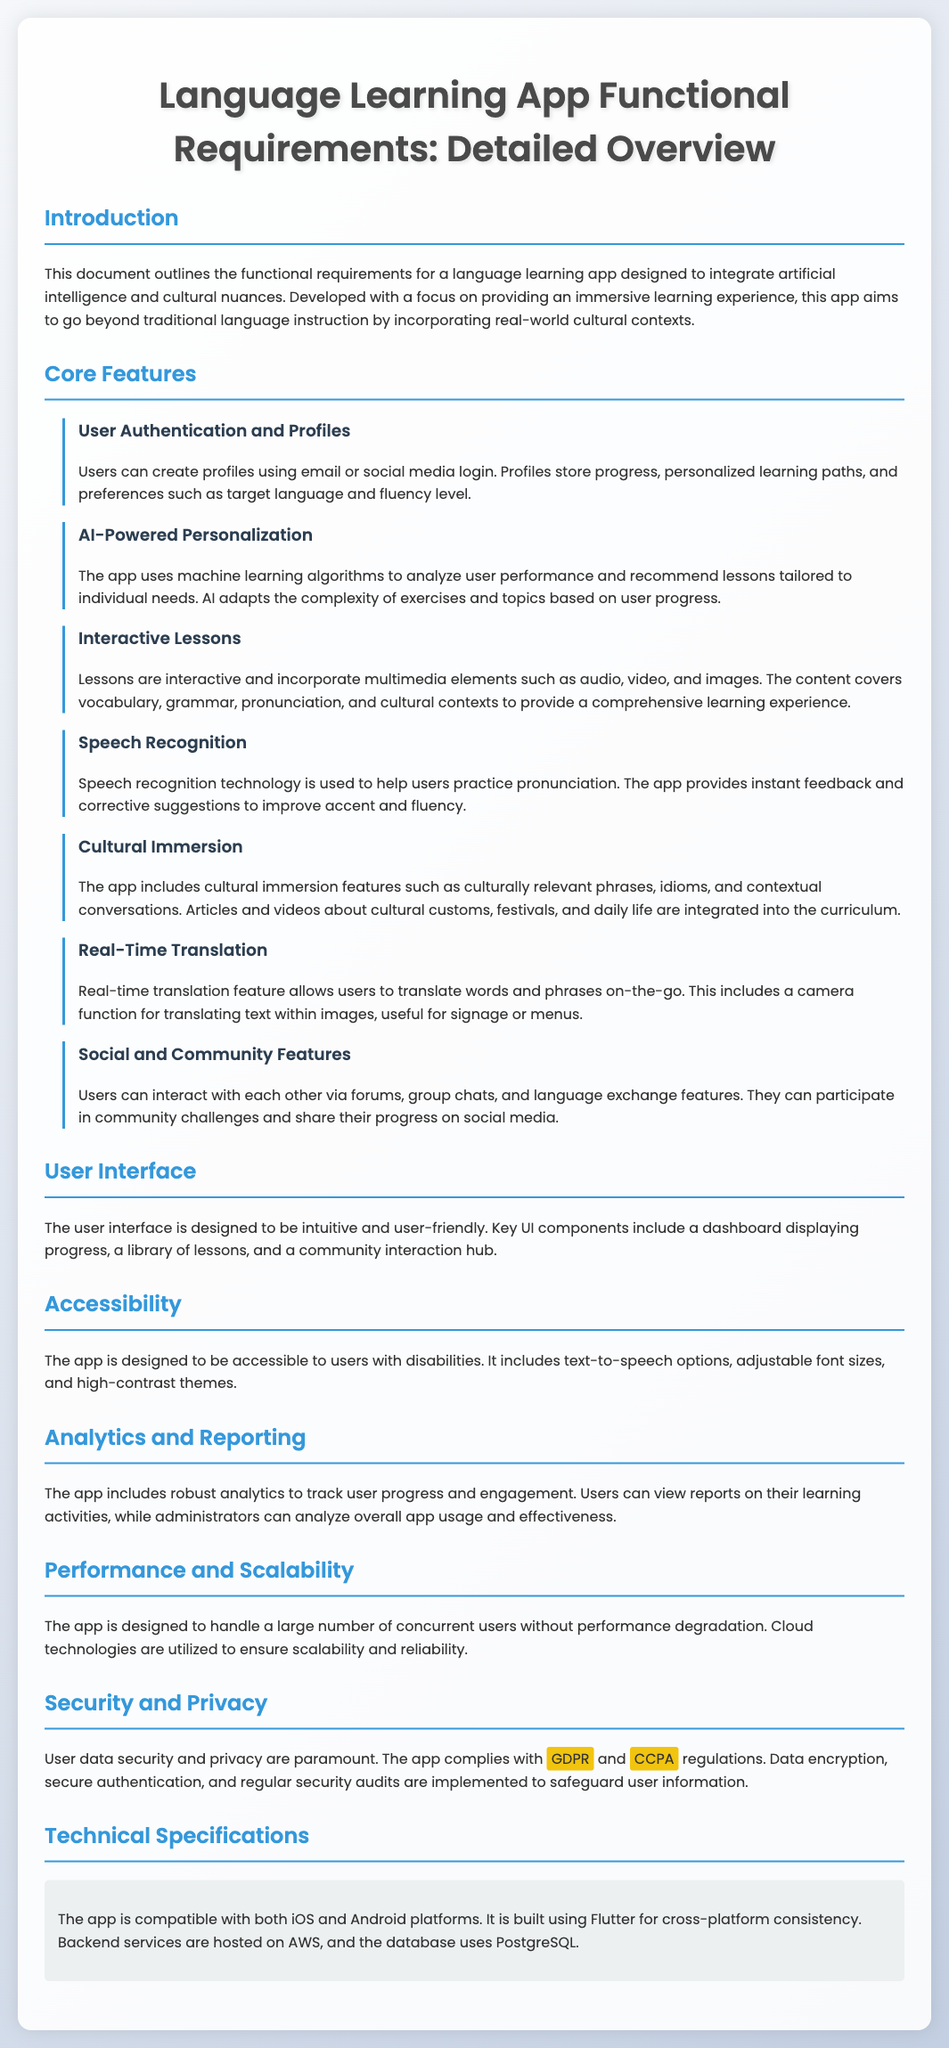What is the main focus of the app? The main focus of the app is to provide an immersive learning experience by incorporating real-world cultural contexts.
Answer: Immersive learning experience How does the app personalize user learning? The app personalizes user learning using machine learning algorithms to analyze performance and recommend lessons tailored to individual needs.
Answer: Machine learning algorithms What technology is used for user authentication? Users can create profiles using email or social media login for authentication.
Answer: Email or social media login What feature helps users practice pronunciation? The app uses speech recognition technology to help users practice pronunciation.
Answer: Speech recognition technology How is user data secured? User data security is ensured through data encryption, secure authentication, and regular security audits.
Answer: Data encryption, secure authentication, and regular security audits What is the platform compatibility of the app? The app is compatible with both iOS and Android platforms.
Answer: iOS and Android How many core features are listed in the document? The document lists seven core features related to the app.
Answer: Seven core features Which regulations does the app comply with? The app complies with GDPR and CCPA regulations.
Answer: GDPR and CCPA 